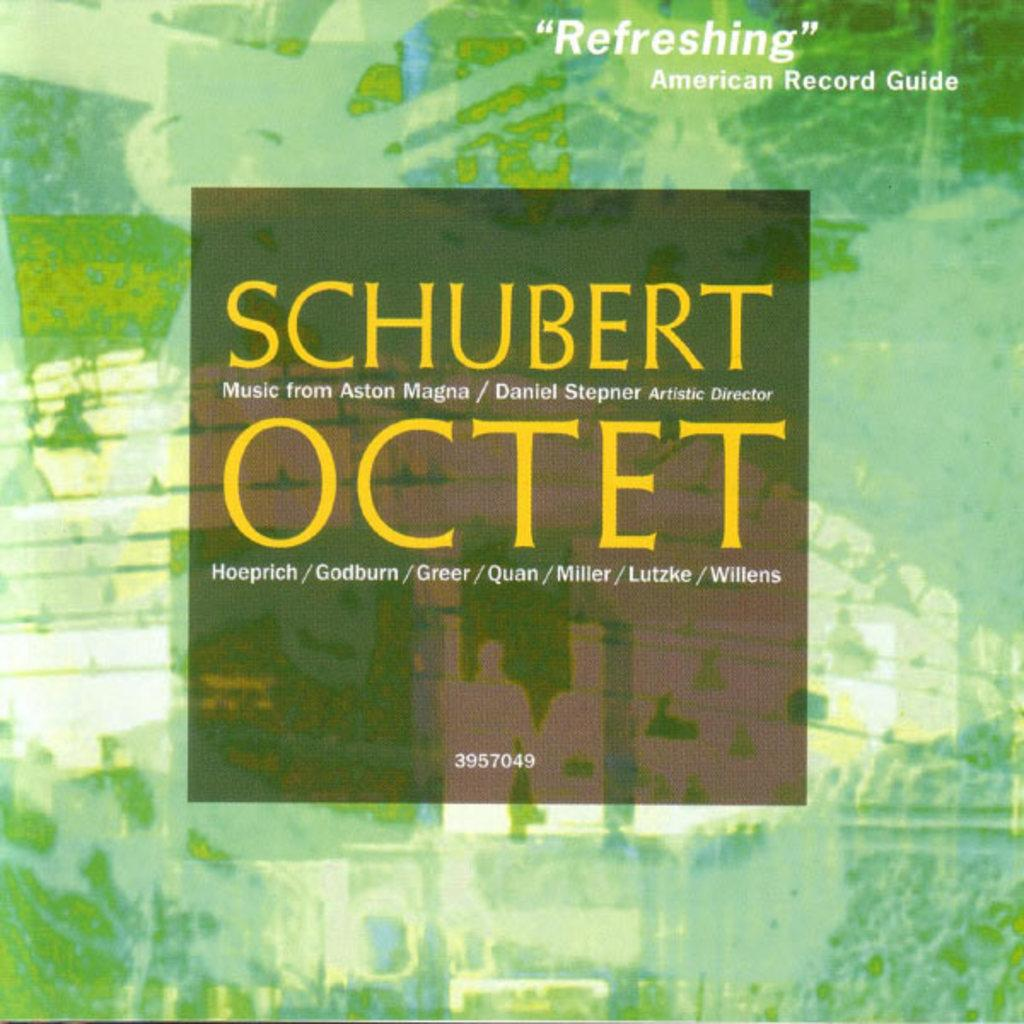<image>
Present a compact description of the photo's key features. A CD of Schubert's Ocetet. The cover is green watercolor. A testimonial quote on the cover says "Refreshing - American Record Guide" 